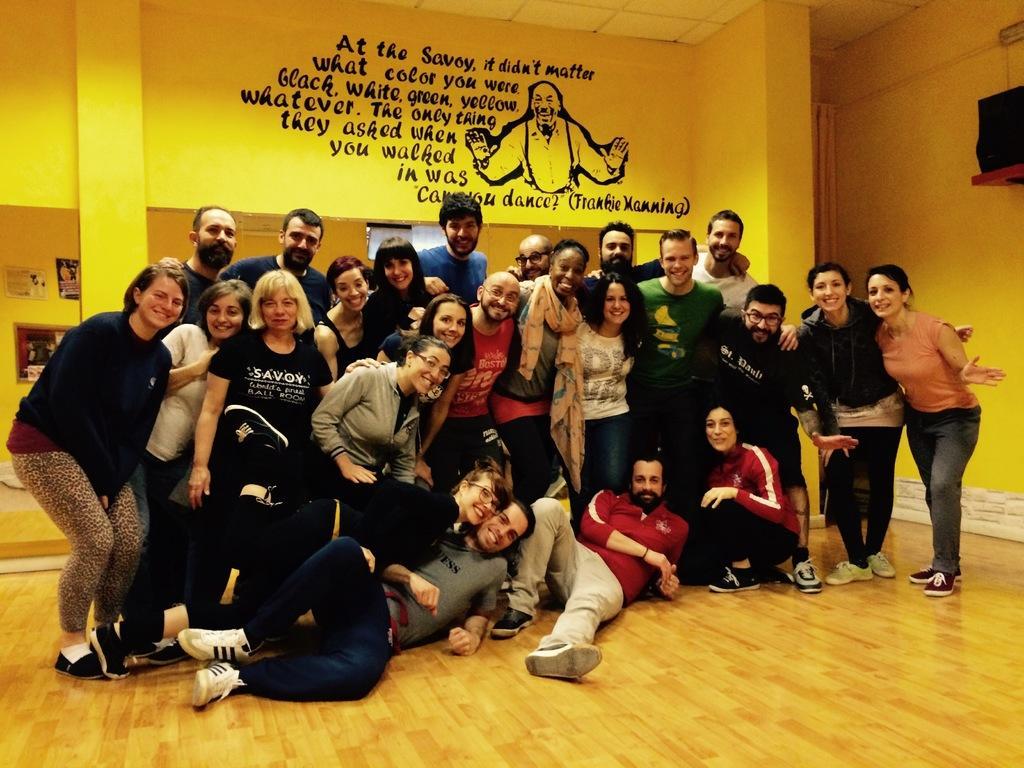How would you summarize this image in a sentence or two? In this image, we can see people standing and some are lying and one of them is bending on the knees. In the background, there are posters on the wall and we can see some text and a picture and there is another object. At the bottom, there is a floor. 